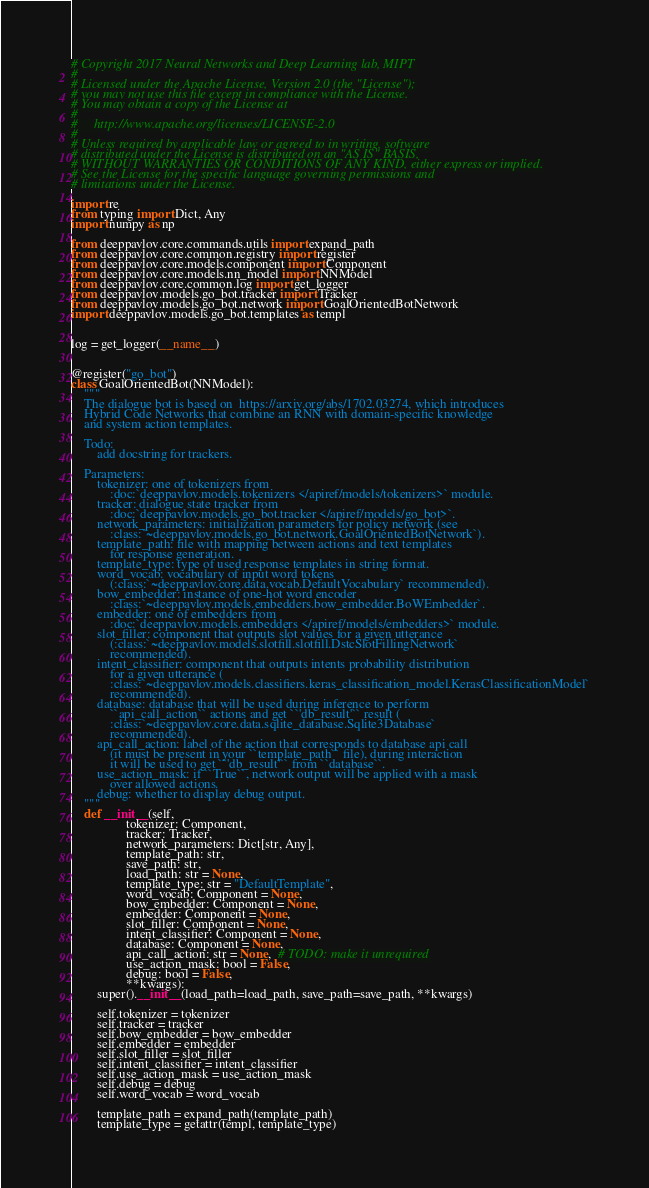<code> <loc_0><loc_0><loc_500><loc_500><_Python_># Copyright 2017 Neural Networks and Deep Learning lab, MIPT
#
# Licensed under the Apache License, Version 2.0 (the "License");
# you may not use this file except in compliance with the License.
# You may obtain a copy of the License at
#
#     http://www.apache.org/licenses/LICENSE-2.0
#
# Unless required by applicable law or agreed to in writing, software
# distributed under the License is distributed on an "AS IS" BASIS,
# WITHOUT WARRANTIES OR CONDITIONS OF ANY KIND, either express or implied.
# See the License for the specific language governing permissions and
# limitations under the License.

import re
from typing import Dict, Any
import numpy as np

from deeppavlov.core.commands.utils import expand_path
from deeppavlov.core.common.registry import register
from deeppavlov.core.models.component import Component
from deeppavlov.core.models.nn_model import NNModel
from deeppavlov.core.common.log import get_logger
from deeppavlov.models.go_bot.tracker import Tracker
from deeppavlov.models.go_bot.network import GoalOrientedBotNetwork
import deeppavlov.models.go_bot.templates as templ


log = get_logger(__name__)


@register("go_bot")
class GoalOrientedBot(NNModel):
    """
    The dialogue bot is based on  https://arxiv.org/abs/1702.03274, which introduces
    Hybrid Code Networks that combine an RNN with domain-specific knowledge
    and system action templates.

    Todo:
        add docstring for trackers.

    Parameters:
        tokenizer: one of tokenizers from
            :doc:`deeppavlov.models.tokenizers </apiref/models/tokenizers>` module.
        tracker: dialogue state tracker from
            :doc:`deeppavlov.models.go_bot.tracker </apiref/models/go_bot>`.
        network_parameters: initialization parameters for policy network (see
            :class:`~deeppavlov.models.go_bot.network.GoalOrientedBotNetwork`).
        template_path: file with mapping between actions and text templates
            for response generation.
        template_type: type of used response templates in string format.
        word_vocab: vocabulary of input word tokens
            (:class:`~deeppavlov.core.data.vocab.DefaultVocabulary` recommended).
        bow_embedder: instance of one-hot word encoder
            :class:`~deeppavlov.models.embedders.bow_embedder.BoWEmbedder`.
        embedder: one of embedders from
            :doc:`deeppavlov.models.embedders </apiref/models/embedders>` module.
        slot_filler: component that outputs slot values for a given utterance
            (:class:`~deeppavlov.models.slotfill.slotfill.DstcSlotFillingNetwork`
            recommended).
        intent_classifier: component that outputs intents probability distribution
            for a given utterance (
            :class:`~deeppavlov.models.classifiers.keras_classification_model.KerasClassificationModel`
            recommended).
        database: database that will be used during inference to perform
            ``api_call_action`` actions and get ``'db_result'`` result (
            :class:`~deeppavlov.core.data.sqlite_database.Sqlite3Database`
            recommended).
        api_call_action: label of the action that corresponds to database api call
            (it must be present in your ``template_path`` file), during interaction
            it will be used to get ``'db_result'`` from ``database``.
        use_action_mask: if ``True``, network output will be applied with a mask
            over allowed actions.
        debug: whether to display debug output.
    """
    def __init__(self,
                 tokenizer: Component,
                 tracker: Tracker,
                 network_parameters: Dict[str, Any],
                 template_path: str,
                 save_path: str,
                 load_path: str = None,
                 template_type: str = "DefaultTemplate",
                 word_vocab: Component = None,
                 bow_embedder: Component = None,
                 embedder: Component = None,
                 slot_filler: Component = None,
                 intent_classifier: Component = None,
                 database: Component = None,
                 api_call_action: str = None,  # TODO: make it unrequired
                 use_action_mask: bool = False,
                 debug: bool = False,
                 **kwargs):
        super().__init__(load_path=load_path, save_path=save_path, **kwargs)

        self.tokenizer = tokenizer
        self.tracker = tracker
        self.bow_embedder = bow_embedder
        self.embedder = embedder
        self.slot_filler = slot_filler
        self.intent_classifier = intent_classifier
        self.use_action_mask = use_action_mask
        self.debug = debug
        self.word_vocab = word_vocab

        template_path = expand_path(template_path)
        template_type = getattr(templ, template_type)</code> 